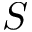Convert formula to latex. <formula><loc_0><loc_0><loc_500><loc_500>S</formula> 